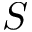Convert formula to latex. <formula><loc_0><loc_0><loc_500><loc_500>S</formula> 